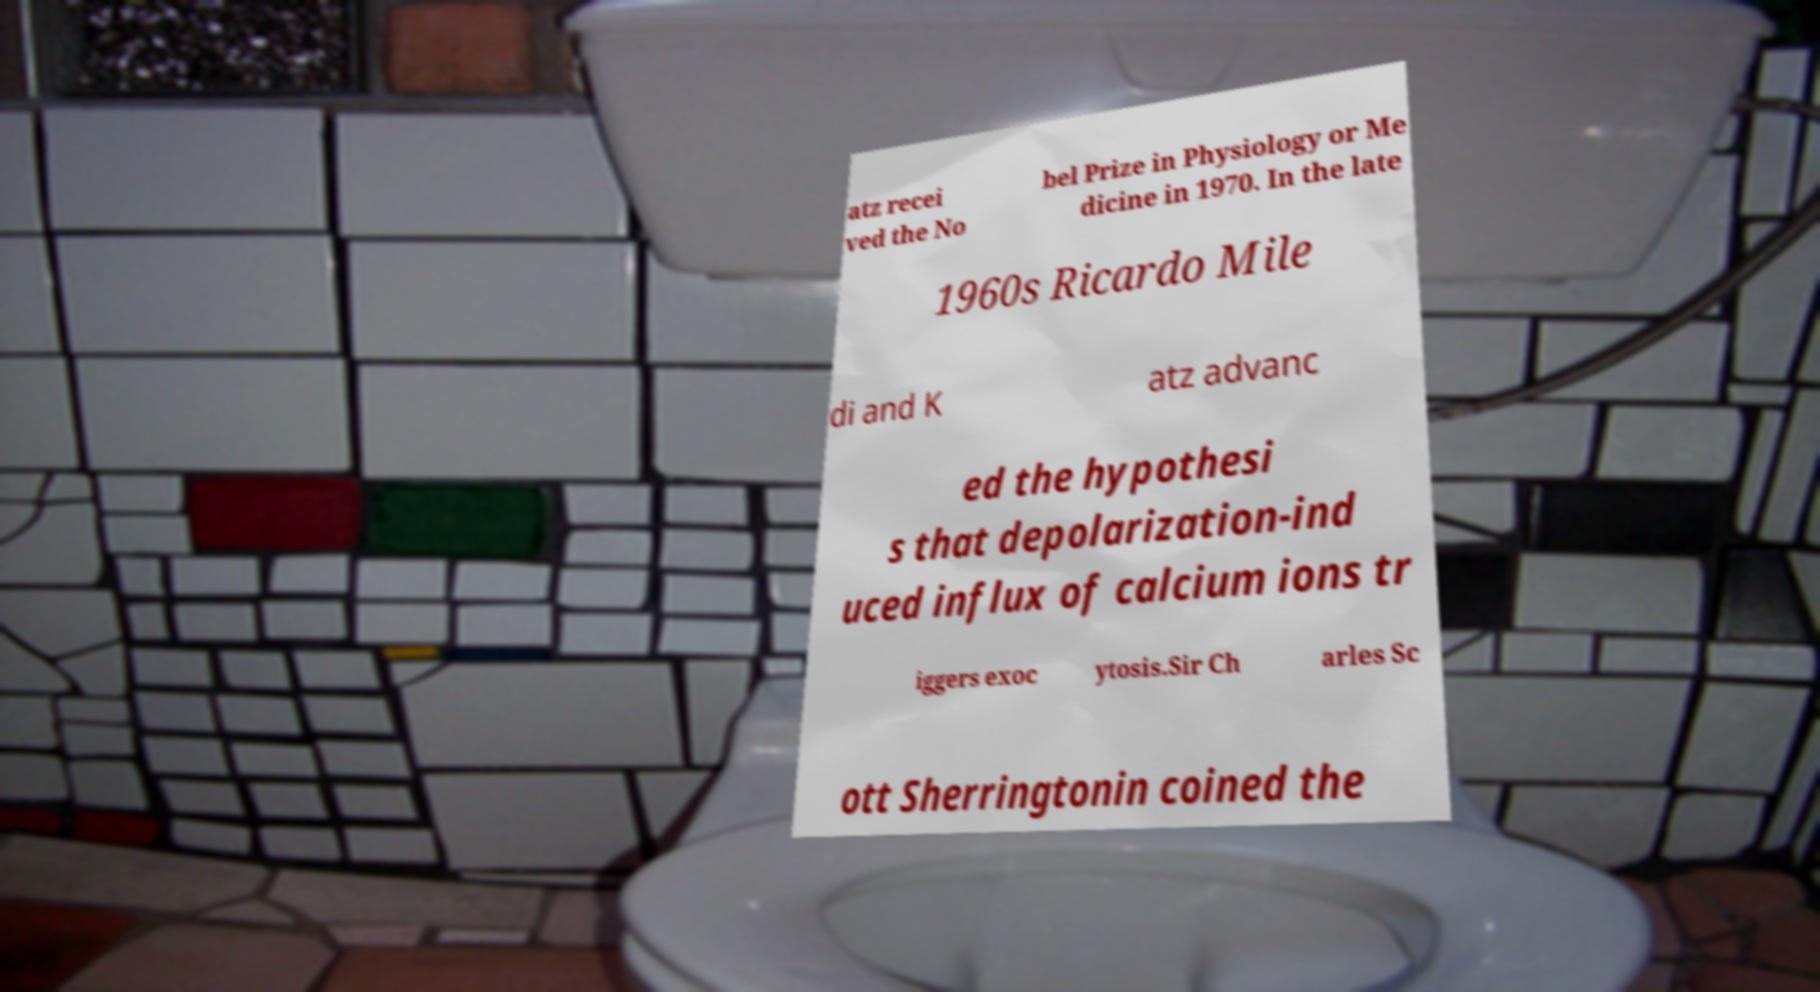What messages or text are displayed in this image? I need them in a readable, typed format. atz recei ved the No bel Prize in Physiology or Me dicine in 1970. In the late 1960s Ricardo Mile di and K atz advanc ed the hypothesi s that depolarization-ind uced influx of calcium ions tr iggers exoc ytosis.Sir Ch arles Sc ott Sherringtonin coined the 